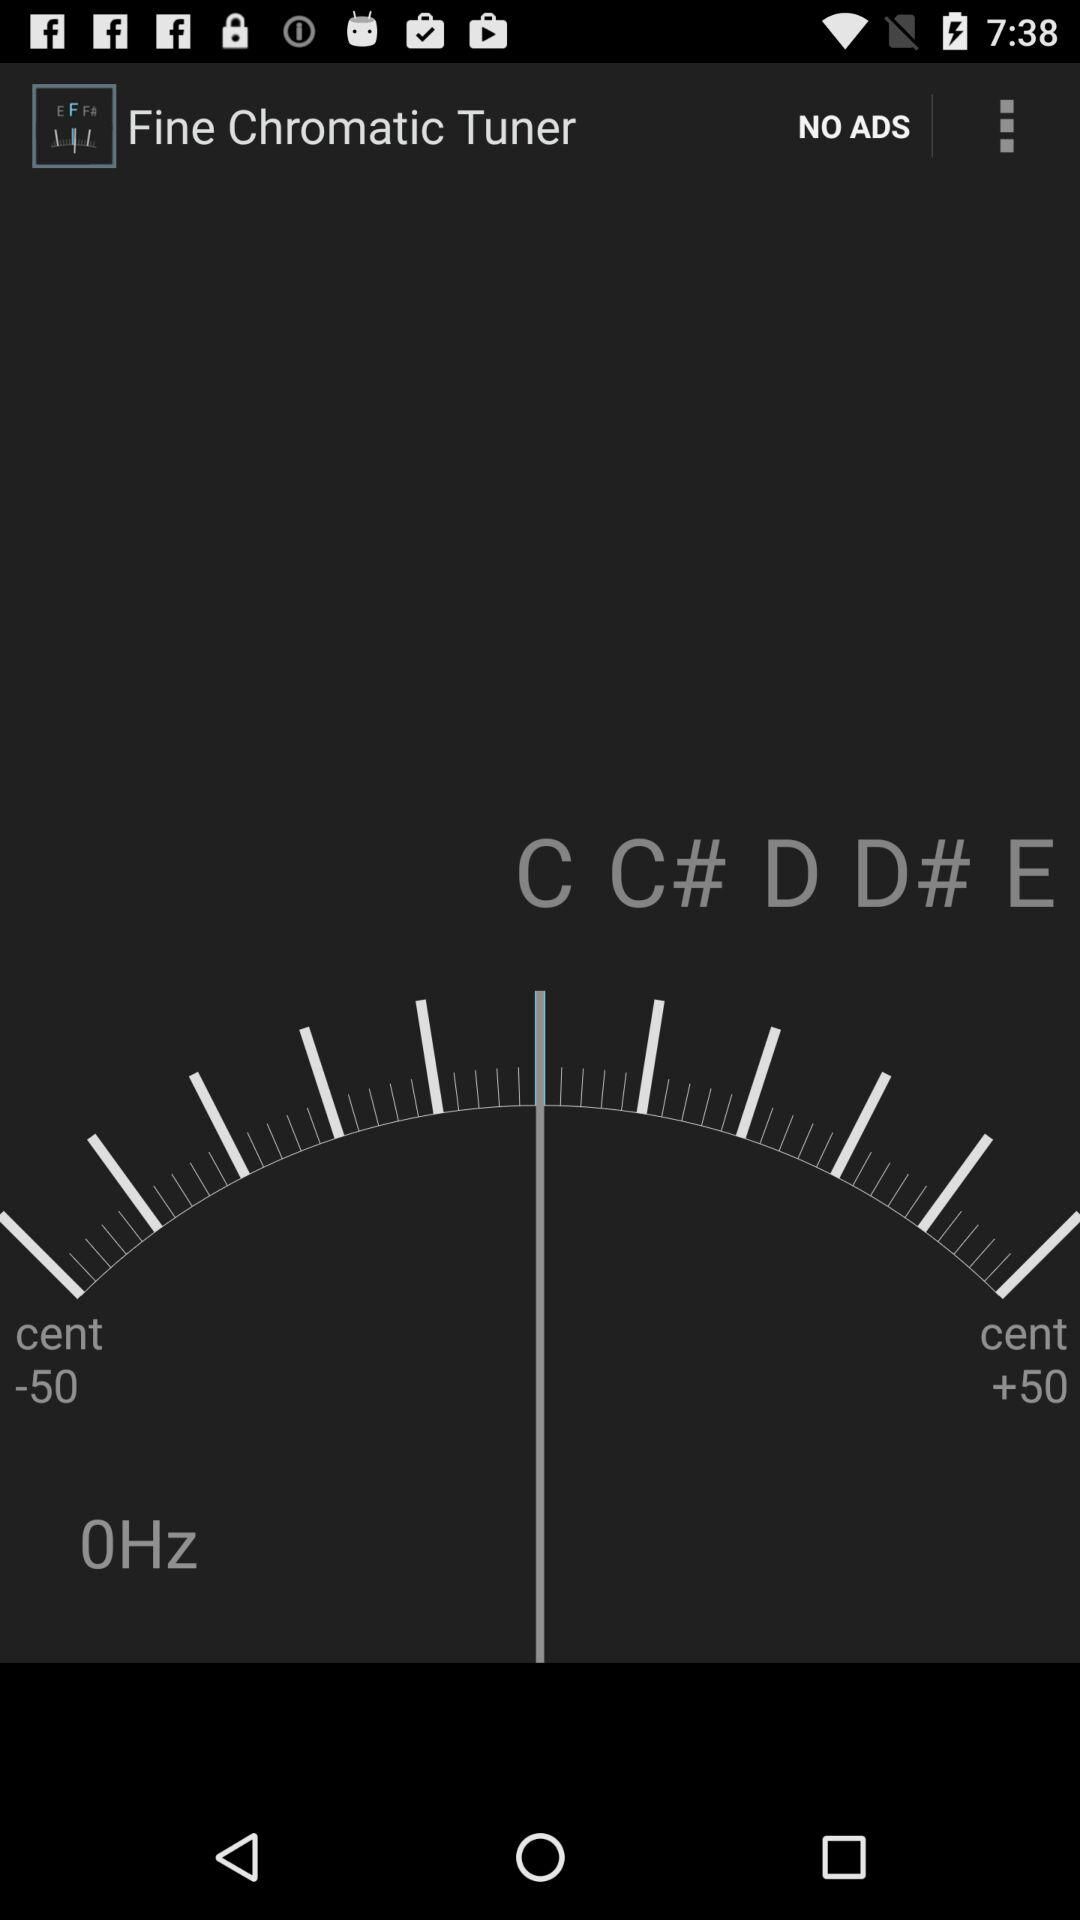What is the difference in value between the cent -50 and cent +50 values?
Answer the question using a single word or phrase. 100 